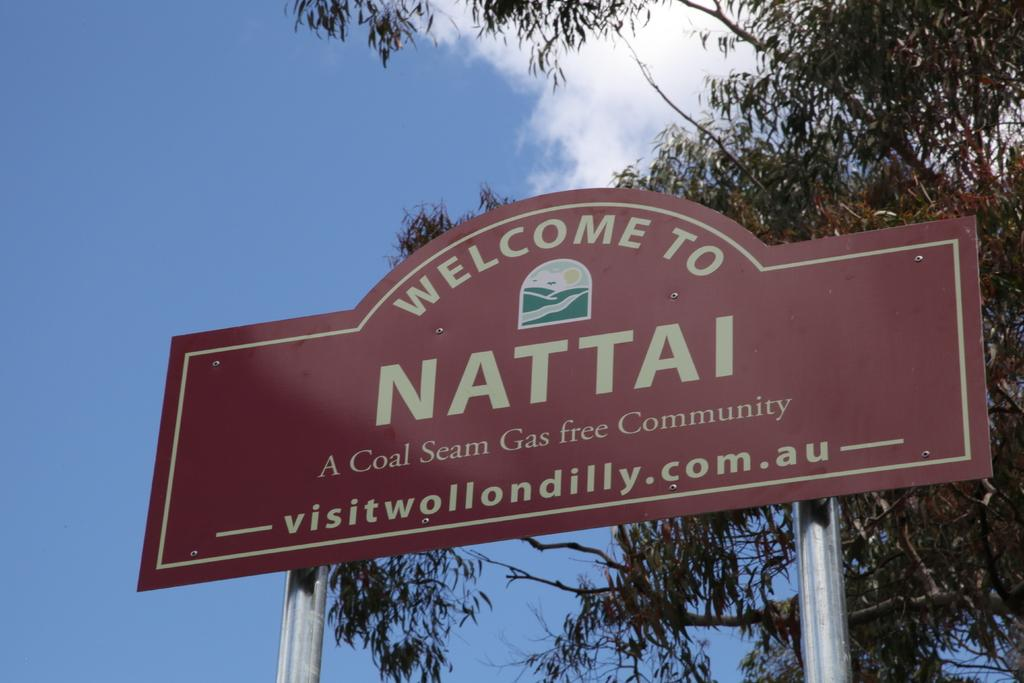What is the main object in the image? There is a board in the image. What else can be seen in the image besides the board? There are two poles and a tree visible in the image. What is written or printed on the board? There is printed text on the board. How would you describe the sky in the image? The sky is cloudy and blue in the image. What type of jeans is the tree wearing in the image? There are no jeans present in the image, as trees do not wear clothing. 